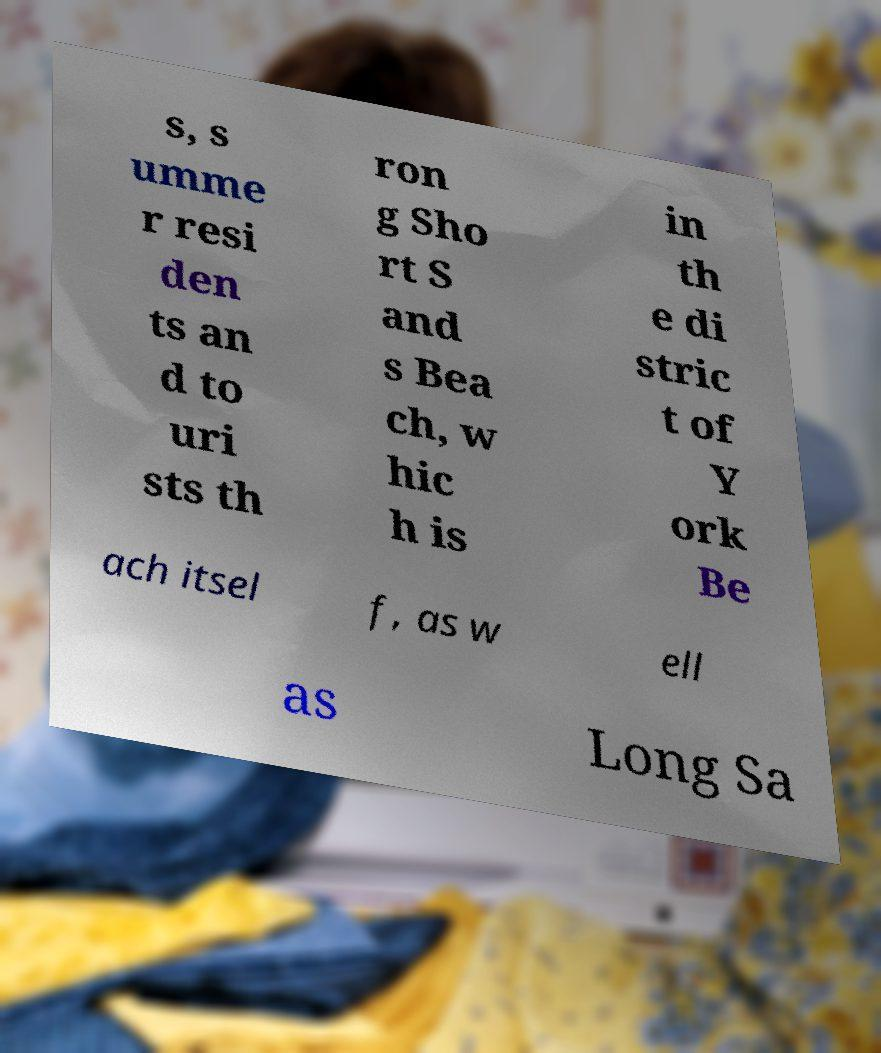Please identify and transcribe the text found in this image. s, s umme r resi den ts an d to uri sts th ron g Sho rt S and s Bea ch, w hic h is in th e di stric t of Y ork Be ach itsel f, as w ell as Long Sa 